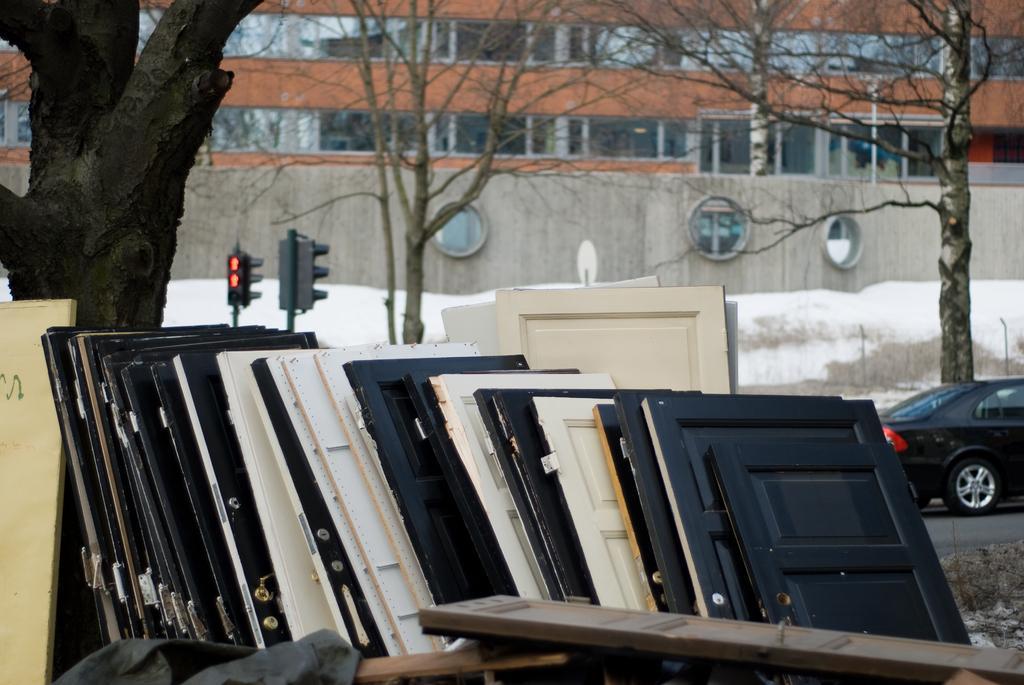Can you describe this image briefly? In this picture I can see many wooden doors which are kept near to the road and tree. On the road there is a black car. In the back there are traffic signals near to the snow. In the background i can see the building. 